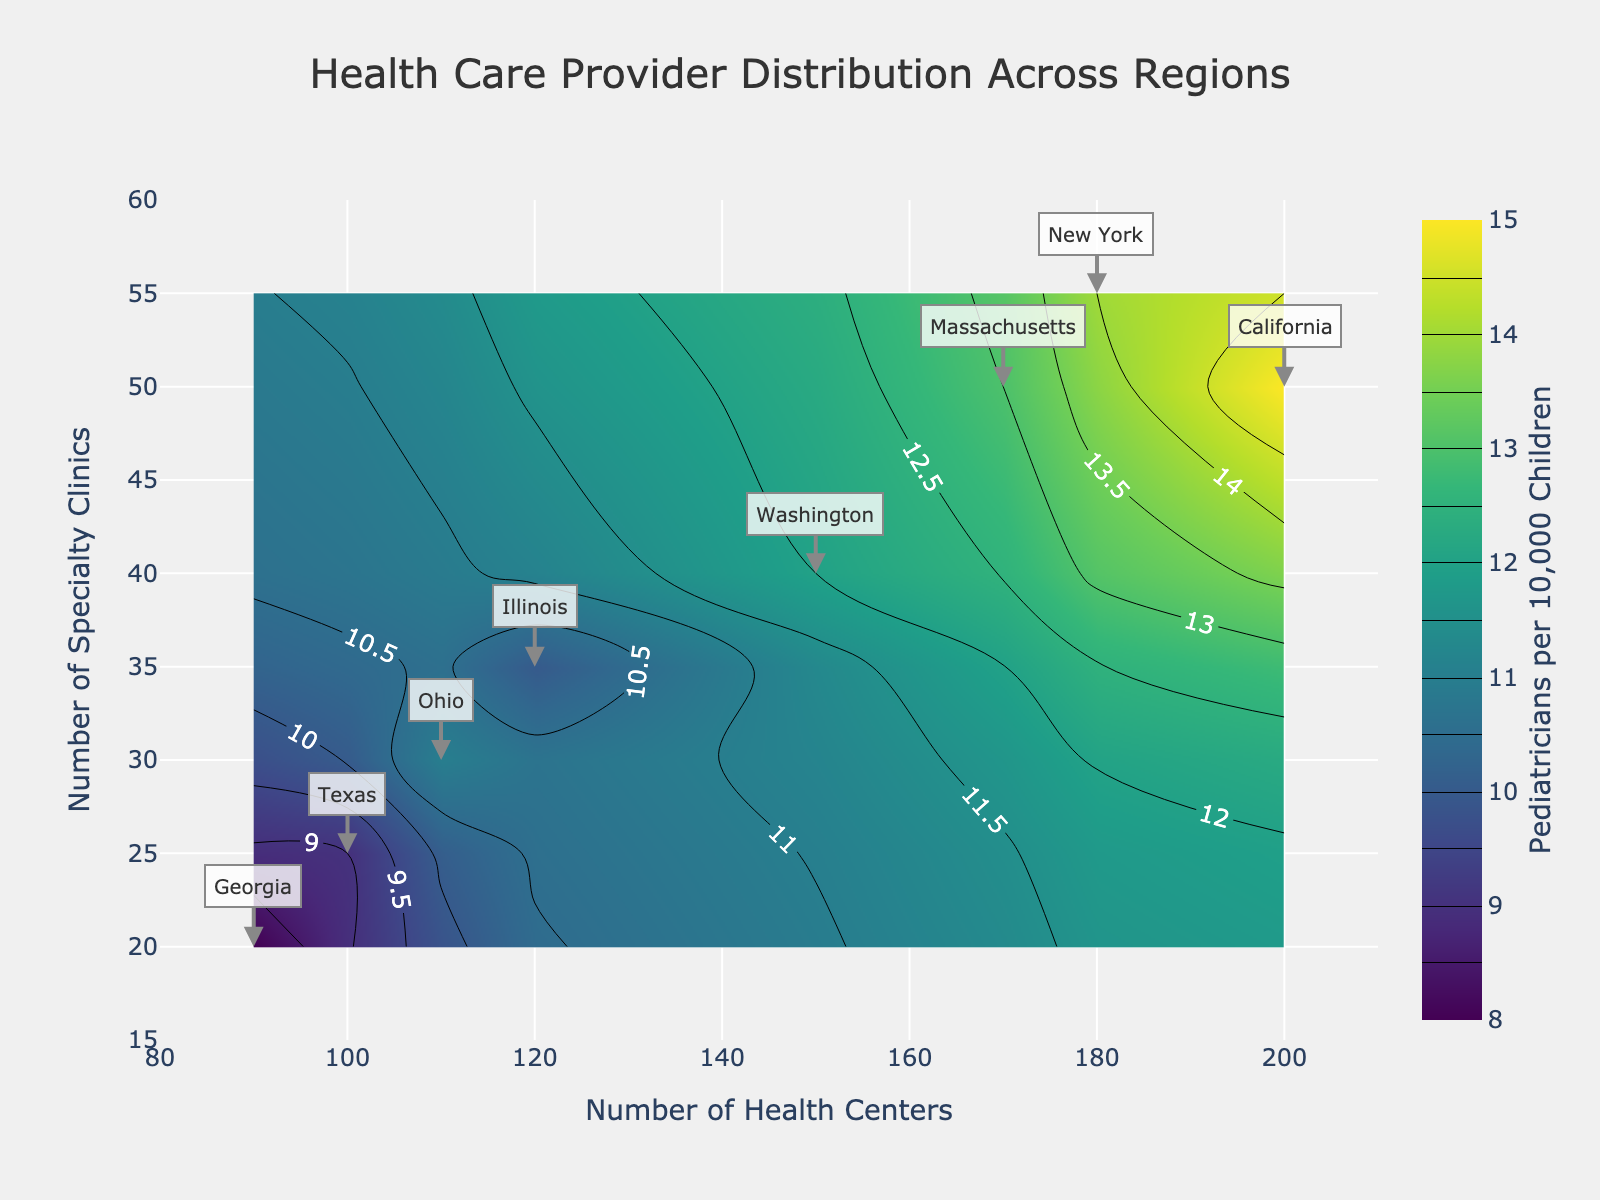How many states are represented in the figure? The plot includes health care data for California, Washington, Illinois, Ohio, New York, Massachusetts, Texas, and Georgia. Counting each state provides the total number of states.
Answer: 8 Which state has the highest number of health centers? By looking at the x-axis, California has the highest number of health centers, located at 200.
Answer: California In which quadrant (top-left, top-right, bottom-left, bottom-right) does New York fall? New York is plotted at (180, 55) for health centers and specialty clinics, respectively. This places it in the top-right quadrant relative to the given axis ranges.
Answer: Top-right What is the range of pediatricians per 10,000 children across all states? The colorbar for 'Pediatricians per 10,000 Children' shows values from the lowest of around 8 to the highest of approximately 15.
Answer: 8 to 15 Which region has the lowest average number of pediatricians per 10,000 children? Calculate the average pediatricians per 10,000 children for each region: 
- West (California: 15, Washington: 12) => (15+12)/2 = 13.5 
- Midwest (Illinois: 10, Ohio: 11) => (10+11)/2 = 10.5
- Northeast (New York: 14, Massachusetts: 13) => (14+13)/2 = 13.5
- South (Texas: 9, Georgia: 8) => (9+8)/2 = 8.5
The South region has the lowest average value.
Answer: South How does the number of health centers in Massachusetts compare to those in New York? Massachusetts has 170 health centers, while New York has 180 health centers, indicating that Massachusetts has 10 fewer health centers than New York.
Answer: Massachusetts has 10 fewer health centers What is the relationship between the number of specialty clinics and pediatricians per 10,000 children in the Midwest region? Illinois has 35 specialty clinics and 10 pediatricians, while Ohio has 30 specialty clinics and 11 pediatricians. There is a slight increase in pediatricians with a slight decrease in specialty clinics.
Answer: Slight inverse relationship Which state has the closest number of health centers and specialty clinics? By examining the labels, Washington shows values of 150 health centers and 40 specialty clinics, which are quite close in number compared to other states.
Answer: Washington In which region is the variance of the number of pediatricians per 10,000 children the highest? Calculate the variance for each region:
- West (California: 15, Washington: 12) => Variance = ((15-13.5)^2 + (12-13.5)^2)/2 = 2.25 
- Midwest (Illinois: 10, Ohio: 11) => Variance = ((10-10.5)^2 + (11-10.5)^2)/2 = 0.25 
- Northeast (New York: 14, Massachusetts: 13) => Variance = ((14-13.5)^2 + (13-13.5)^2)/2 = 0.25 
- South (Texas: 9, Georgia: 8) => Variance = ((9-8.5)^2 + (8-8.5)^2)/2 = 0.25
The West region has the highest variance.
Answer: West 